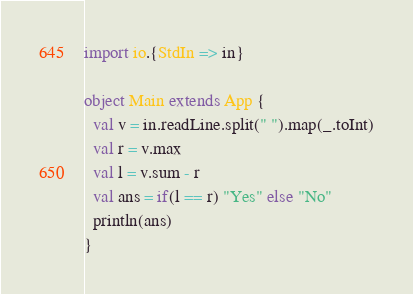<code> <loc_0><loc_0><loc_500><loc_500><_Scala_>import io.{StdIn => in}

object Main extends App {
  val v = in.readLine.split(" ").map(_.toInt)
  val r = v.max
  val l = v.sum - r
  val ans = if(l == r) "Yes" else "No"
  println(ans)
}</code> 